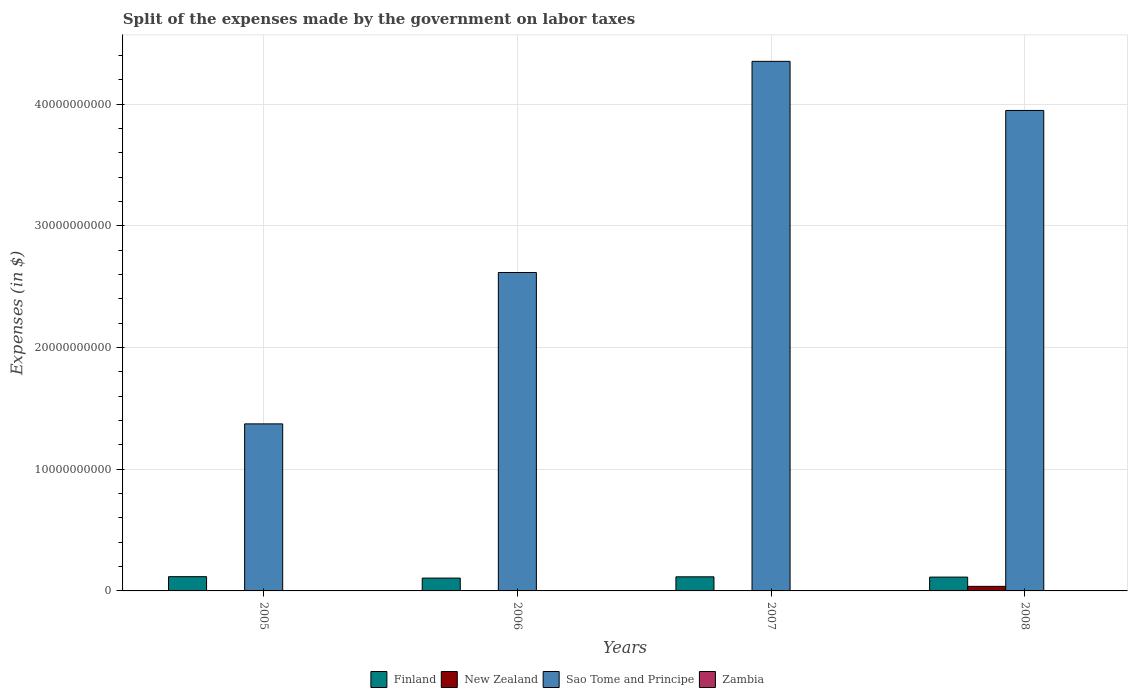Are the number of bars per tick equal to the number of legend labels?
Give a very brief answer. Yes. How many bars are there on the 4th tick from the left?
Ensure brevity in your answer.  4. In how many cases, is the number of bars for a given year not equal to the number of legend labels?
Offer a terse response. 0. What is the expenses made by the government on labor taxes in Finland in 2006?
Ensure brevity in your answer.  1.06e+09. Across all years, what is the maximum expenses made by the government on labor taxes in Sao Tome and Principe?
Keep it short and to the point. 4.35e+1. In which year was the expenses made by the government on labor taxes in Zambia minimum?
Offer a very short reply. 2005. What is the total expenses made by the government on labor taxes in Sao Tome and Principe in the graph?
Give a very brief answer. 1.23e+11. What is the difference between the expenses made by the government on labor taxes in Finland in 2007 and that in 2008?
Offer a terse response. 2.30e+07. What is the difference between the expenses made by the government on labor taxes in Zambia in 2008 and the expenses made by the government on labor taxes in Sao Tome and Principe in 2006?
Your answer should be compact. -2.61e+1. What is the average expenses made by the government on labor taxes in Zambia per year?
Your answer should be compact. 1.92e+07. In the year 2005, what is the difference between the expenses made by the government on labor taxes in Sao Tome and Principe and expenses made by the government on labor taxes in Finland?
Offer a terse response. 1.26e+1. In how many years, is the expenses made by the government on labor taxes in Zambia greater than 8000000000 $?
Offer a very short reply. 0. What is the ratio of the expenses made by the government on labor taxes in Finland in 2005 to that in 2008?
Give a very brief answer. 1.03. Is the difference between the expenses made by the government on labor taxes in Sao Tome and Principe in 2006 and 2008 greater than the difference between the expenses made by the government on labor taxes in Finland in 2006 and 2008?
Offer a terse response. No. What is the difference between the highest and the second highest expenses made by the government on labor taxes in Sao Tome and Principe?
Offer a terse response. 4.03e+09. What is the difference between the highest and the lowest expenses made by the government on labor taxes in New Zealand?
Your answer should be very brief. 3.73e+08. Is it the case that in every year, the sum of the expenses made by the government on labor taxes in Zambia and expenses made by the government on labor taxes in Sao Tome and Principe is greater than the sum of expenses made by the government on labor taxes in Finland and expenses made by the government on labor taxes in New Zealand?
Offer a terse response. Yes. What does the 2nd bar from the left in 2007 represents?
Your answer should be very brief. New Zealand. What does the 1st bar from the right in 2005 represents?
Provide a short and direct response. Zambia. Is it the case that in every year, the sum of the expenses made by the government on labor taxes in Finland and expenses made by the government on labor taxes in New Zealand is greater than the expenses made by the government on labor taxes in Zambia?
Offer a terse response. Yes. Does the graph contain any zero values?
Offer a very short reply. No. What is the title of the graph?
Provide a short and direct response. Split of the expenses made by the government on labor taxes. Does "Dominican Republic" appear as one of the legend labels in the graph?
Provide a short and direct response. No. What is the label or title of the Y-axis?
Your answer should be compact. Expenses (in $). What is the Expenses (in $) of Finland in 2005?
Make the answer very short. 1.17e+09. What is the Expenses (in $) in New Zealand in 2005?
Your response must be concise. 2.32e+06. What is the Expenses (in $) in Sao Tome and Principe in 2005?
Your answer should be very brief. 1.37e+1. What is the Expenses (in $) of Zambia in 2005?
Offer a terse response. 1.21e+07. What is the Expenses (in $) of Finland in 2006?
Your response must be concise. 1.06e+09. What is the Expenses (in $) in New Zealand in 2006?
Provide a succinct answer. 3.00e+06. What is the Expenses (in $) in Sao Tome and Principe in 2006?
Your answer should be very brief. 2.62e+1. What is the Expenses (in $) in Zambia in 2006?
Provide a short and direct response. 1.84e+07. What is the Expenses (in $) in Finland in 2007?
Offer a terse response. 1.16e+09. What is the Expenses (in $) in New Zealand in 2007?
Provide a succinct answer. 2.00e+06. What is the Expenses (in $) of Sao Tome and Principe in 2007?
Provide a succinct answer. 4.35e+1. What is the Expenses (in $) in Zambia in 2007?
Offer a very short reply. 2.33e+07. What is the Expenses (in $) of Finland in 2008?
Keep it short and to the point. 1.14e+09. What is the Expenses (in $) of New Zealand in 2008?
Make the answer very short. 3.75e+08. What is the Expenses (in $) in Sao Tome and Principe in 2008?
Ensure brevity in your answer.  3.95e+1. What is the Expenses (in $) in Zambia in 2008?
Give a very brief answer. 2.31e+07. Across all years, what is the maximum Expenses (in $) of Finland?
Keep it short and to the point. 1.17e+09. Across all years, what is the maximum Expenses (in $) of New Zealand?
Keep it short and to the point. 3.75e+08. Across all years, what is the maximum Expenses (in $) of Sao Tome and Principe?
Provide a succinct answer. 4.35e+1. Across all years, what is the maximum Expenses (in $) of Zambia?
Make the answer very short. 2.33e+07. Across all years, what is the minimum Expenses (in $) of Finland?
Keep it short and to the point. 1.06e+09. Across all years, what is the minimum Expenses (in $) of New Zealand?
Your answer should be very brief. 2.00e+06. Across all years, what is the minimum Expenses (in $) in Sao Tome and Principe?
Your response must be concise. 1.37e+1. Across all years, what is the minimum Expenses (in $) of Zambia?
Provide a succinct answer. 1.21e+07. What is the total Expenses (in $) in Finland in the graph?
Offer a very short reply. 4.52e+09. What is the total Expenses (in $) of New Zealand in the graph?
Keep it short and to the point. 3.82e+08. What is the total Expenses (in $) of Sao Tome and Principe in the graph?
Provide a short and direct response. 1.23e+11. What is the total Expenses (in $) of Zambia in the graph?
Offer a very short reply. 7.69e+07. What is the difference between the Expenses (in $) of Finland in 2005 and that in 2006?
Your answer should be compact. 1.15e+08. What is the difference between the Expenses (in $) in New Zealand in 2005 and that in 2006?
Your answer should be compact. -6.75e+05. What is the difference between the Expenses (in $) in Sao Tome and Principe in 2005 and that in 2006?
Give a very brief answer. -1.24e+1. What is the difference between the Expenses (in $) of Zambia in 2005 and that in 2006?
Ensure brevity in your answer.  -6.34e+06. What is the difference between the Expenses (in $) in New Zealand in 2005 and that in 2007?
Offer a very short reply. 3.25e+05. What is the difference between the Expenses (in $) in Sao Tome and Principe in 2005 and that in 2007?
Your response must be concise. -2.98e+1. What is the difference between the Expenses (in $) in Zambia in 2005 and that in 2007?
Provide a short and direct response. -1.13e+07. What is the difference between the Expenses (in $) of Finland in 2005 and that in 2008?
Offer a terse response. 3.50e+07. What is the difference between the Expenses (in $) in New Zealand in 2005 and that in 2008?
Offer a very short reply. -3.73e+08. What is the difference between the Expenses (in $) of Sao Tome and Principe in 2005 and that in 2008?
Your response must be concise. -2.57e+1. What is the difference between the Expenses (in $) of Zambia in 2005 and that in 2008?
Offer a terse response. -1.11e+07. What is the difference between the Expenses (in $) in Finland in 2006 and that in 2007?
Offer a very short reply. -1.03e+08. What is the difference between the Expenses (in $) in New Zealand in 2006 and that in 2007?
Your answer should be compact. 1.00e+06. What is the difference between the Expenses (in $) of Sao Tome and Principe in 2006 and that in 2007?
Your answer should be very brief. -1.73e+1. What is the difference between the Expenses (in $) of Zambia in 2006 and that in 2007?
Keep it short and to the point. -4.95e+06. What is the difference between the Expenses (in $) of Finland in 2006 and that in 2008?
Offer a very short reply. -8.00e+07. What is the difference between the Expenses (in $) in New Zealand in 2006 and that in 2008?
Your response must be concise. -3.72e+08. What is the difference between the Expenses (in $) in Sao Tome and Principe in 2006 and that in 2008?
Keep it short and to the point. -1.33e+1. What is the difference between the Expenses (in $) of Zambia in 2006 and that in 2008?
Provide a succinct answer. -4.72e+06. What is the difference between the Expenses (in $) in Finland in 2007 and that in 2008?
Your answer should be very brief. 2.30e+07. What is the difference between the Expenses (in $) in New Zealand in 2007 and that in 2008?
Your answer should be compact. -3.73e+08. What is the difference between the Expenses (in $) in Sao Tome and Principe in 2007 and that in 2008?
Make the answer very short. 4.03e+09. What is the difference between the Expenses (in $) in Zambia in 2007 and that in 2008?
Keep it short and to the point. 2.22e+05. What is the difference between the Expenses (in $) in Finland in 2005 and the Expenses (in $) in New Zealand in 2006?
Your answer should be compact. 1.17e+09. What is the difference between the Expenses (in $) in Finland in 2005 and the Expenses (in $) in Sao Tome and Principe in 2006?
Your answer should be very brief. -2.50e+1. What is the difference between the Expenses (in $) in Finland in 2005 and the Expenses (in $) in Zambia in 2006?
Provide a short and direct response. 1.15e+09. What is the difference between the Expenses (in $) of New Zealand in 2005 and the Expenses (in $) of Sao Tome and Principe in 2006?
Provide a succinct answer. -2.62e+1. What is the difference between the Expenses (in $) in New Zealand in 2005 and the Expenses (in $) in Zambia in 2006?
Keep it short and to the point. -1.61e+07. What is the difference between the Expenses (in $) in Sao Tome and Principe in 2005 and the Expenses (in $) in Zambia in 2006?
Your answer should be very brief. 1.37e+1. What is the difference between the Expenses (in $) of Finland in 2005 and the Expenses (in $) of New Zealand in 2007?
Your answer should be compact. 1.17e+09. What is the difference between the Expenses (in $) in Finland in 2005 and the Expenses (in $) in Sao Tome and Principe in 2007?
Give a very brief answer. -4.23e+1. What is the difference between the Expenses (in $) in Finland in 2005 and the Expenses (in $) in Zambia in 2007?
Ensure brevity in your answer.  1.15e+09. What is the difference between the Expenses (in $) in New Zealand in 2005 and the Expenses (in $) in Sao Tome and Principe in 2007?
Keep it short and to the point. -4.35e+1. What is the difference between the Expenses (in $) of New Zealand in 2005 and the Expenses (in $) of Zambia in 2007?
Make the answer very short. -2.10e+07. What is the difference between the Expenses (in $) in Sao Tome and Principe in 2005 and the Expenses (in $) in Zambia in 2007?
Provide a short and direct response. 1.37e+1. What is the difference between the Expenses (in $) in Finland in 2005 and the Expenses (in $) in New Zealand in 2008?
Your response must be concise. 7.95e+08. What is the difference between the Expenses (in $) in Finland in 2005 and the Expenses (in $) in Sao Tome and Principe in 2008?
Ensure brevity in your answer.  -3.83e+1. What is the difference between the Expenses (in $) in Finland in 2005 and the Expenses (in $) in Zambia in 2008?
Offer a very short reply. 1.15e+09. What is the difference between the Expenses (in $) of New Zealand in 2005 and the Expenses (in $) of Sao Tome and Principe in 2008?
Give a very brief answer. -3.95e+1. What is the difference between the Expenses (in $) of New Zealand in 2005 and the Expenses (in $) of Zambia in 2008?
Provide a succinct answer. -2.08e+07. What is the difference between the Expenses (in $) in Sao Tome and Principe in 2005 and the Expenses (in $) in Zambia in 2008?
Your answer should be very brief. 1.37e+1. What is the difference between the Expenses (in $) of Finland in 2006 and the Expenses (in $) of New Zealand in 2007?
Offer a very short reply. 1.05e+09. What is the difference between the Expenses (in $) of Finland in 2006 and the Expenses (in $) of Sao Tome and Principe in 2007?
Your response must be concise. -4.25e+1. What is the difference between the Expenses (in $) in Finland in 2006 and the Expenses (in $) in Zambia in 2007?
Provide a succinct answer. 1.03e+09. What is the difference between the Expenses (in $) of New Zealand in 2006 and the Expenses (in $) of Sao Tome and Principe in 2007?
Your answer should be very brief. -4.35e+1. What is the difference between the Expenses (in $) in New Zealand in 2006 and the Expenses (in $) in Zambia in 2007?
Offer a terse response. -2.03e+07. What is the difference between the Expenses (in $) of Sao Tome and Principe in 2006 and the Expenses (in $) of Zambia in 2007?
Your response must be concise. 2.61e+1. What is the difference between the Expenses (in $) of Finland in 2006 and the Expenses (in $) of New Zealand in 2008?
Offer a terse response. 6.80e+08. What is the difference between the Expenses (in $) of Finland in 2006 and the Expenses (in $) of Sao Tome and Principe in 2008?
Provide a succinct answer. -3.84e+1. What is the difference between the Expenses (in $) in Finland in 2006 and the Expenses (in $) in Zambia in 2008?
Give a very brief answer. 1.03e+09. What is the difference between the Expenses (in $) in New Zealand in 2006 and the Expenses (in $) in Sao Tome and Principe in 2008?
Provide a succinct answer. -3.95e+1. What is the difference between the Expenses (in $) of New Zealand in 2006 and the Expenses (in $) of Zambia in 2008?
Make the answer very short. -2.01e+07. What is the difference between the Expenses (in $) in Sao Tome and Principe in 2006 and the Expenses (in $) in Zambia in 2008?
Provide a succinct answer. 2.61e+1. What is the difference between the Expenses (in $) of Finland in 2007 and the Expenses (in $) of New Zealand in 2008?
Offer a terse response. 7.83e+08. What is the difference between the Expenses (in $) in Finland in 2007 and the Expenses (in $) in Sao Tome and Principe in 2008?
Your response must be concise. -3.83e+1. What is the difference between the Expenses (in $) of Finland in 2007 and the Expenses (in $) of Zambia in 2008?
Keep it short and to the point. 1.13e+09. What is the difference between the Expenses (in $) in New Zealand in 2007 and the Expenses (in $) in Sao Tome and Principe in 2008?
Make the answer very short. -3.95e+1. What is the difference between the Expenses (in $) in New Zealand in 2007 and the Expenses (in $) in Zambia in 2008?
Offer a terse response. -2.11e+07. What is the difference between the Expenses (in $) of Sao Tome and Principe in 2007 and the Expenses (in $) of Zambia in 2008?
Offer a very short reply. 4.35e+1. What is the average Expenses (in $) in Finland per year?
Give a very brief answer. 1.13e+09. What is the average Expenses (in $) of New Zealand per year?
Provide a succinct answer. 9.56e+07. What is the average Expenses (in $) in Sao Tome and Principe per year?
Ensure brevity in your answer.  3.07e+1. What is the average Expenses (in $) of Zambia per year?
Provide a short and direct response. 1.92e+07. In the year 2005, what is the difference between the Expenses (in $) of Finland and Expenses (in $) of New Zealand?
Provide a short and direct response. 1.17e+09. In the year 2005, what is the difference between the Expenses (in $) of Finland and Expenses (in $) of Sao Tome and Principe?
Provide a succinct answer. -1.26e+1. In the year 2005, what is the difference between the Expenses (in $) in Finland and Expenses (in $) in Zambia?
Offer a very short reply. 1.16e+09. In the year 2005, what is the difference between the Expenses (in $) of New Zealand and Expenses (in $) of Sao Tome and Principe?
Make the answer very short. -1.37e+1. In the year 2005, what is the difference between the Expenses (in $) in New Zealand and Expenses (in $) in Zambia?
Give a very brief answer. -9.73e+06. In the year 2005, what is the difference between the Expenses (in $) in Sao Tome and Principe and Expenses (in $) in Zambia?
Your answer should be very brief. 1.37e+1. In the year 2006, what is the difference between the Expenses (in $) of Finland and Expenses (in $) of New Zealand?
Ensure brevity in your answer.  1.05e+09. In the year 2006, what is the difference between the Expenses (in $) of Finland and Expenses (in $) of Sao Tome and Principe?
Your answer should be compact. -2.51e+1. In the year 2006, what is the difference between the Expenses (in $) in Finland and Expenses (in $) in Zambia?
Your response must be concise. 1.04e+09. In the year 2006, what is the difference between the Expenses (in $) in New Zealand and Expenses (in $) in Sao Tome and Principe?
Provide a succinct answer. -2.62e+1. In the year 2006, what is the difference between the Expenses (in $) of New Zealand and Expenses (in $) of Zambia?
Offer a very short reply. -1.54e+07. In the year 2006, what is the difference between the Expenses (in $) of Sao Tome and Principe and Expenses (in $) of Zambia?
Provide a succinct answer. 2.61e+1. In the year 2007, what is the difference between the Expenses (in $) in Finland and Expenses (in $) in New Zealand?
Offer a very short reply. 1.16e+09. In the year 2007, what is the difference between the Expenses (in $) of Finland and Expenses (in $) of Sao Tome and Principe?
Ensure brevity in your answer.  -4.23e+1. In the year 2007, what is the difference between the Expenses (in $) in Finland and Expenses (in $) in Zambia?
Your answer should be very brief. 1.13e+09. In the year 2007, what is the difference between the Expenses (in $) in New Zealand and Expenses (in $) in Sao Tome and Principe?
Offer a terse response. -4.35e+1. In the year 2007, what is the difference between the Expenses (in $) in New Zealand and Expenses (in $) in Zambia?
Your answer should be compact. -2.13e+07. In the year 2007, what is the difference between the Expenses (in $) in Sao Tome and Principe and Expenses (in $) in Zambia?
Your response must be concise. 4.35e+1. In the year 2008, what is the difference between the Expenses (in $) in Finland and Expenses (in $) in New Zealand?
Ensure brevity in your answer.  7.60e+08. In the year 2008, what is the difference between the Expenses (in $) of Finland and Expenses (in $) of Sao Tome and Principe?
Offer a very short reply. -3.83e+1. In the year 2008, what is the difference between the Expenses (in $) of Finland and Expenses (in $) of Zambia?
Provide a succinct answer. 1.11e+09. In the year 2008, what is the difference between the Expenses (in $) in New Zealand and Expenses (in $) in Sao Tome and Principe?
Your answer should be very brief. -3.91e+1. In the year 2008, what is the difference between the Expenses (in $) of New Zealand and Expenses (in $) of Zambia?
Ensure brevity in your answer.  3.52e+08. In the year 2008, what is the difference between the Expenses (in $) of Sao Tome and Principe and Expenses (in $) of Zambia?
Offer a very short reply. 3.94e+1. What is the ratio of the Expenses (in $) in Finland in 2005 to that in 2006?
Your response must be concise. 1.11. What is the ratio of the Expenses (in $) of New Zealand in 2005 to that in 2006?
Your answer should be compact. 0.78. What is the ratio of the Expenses (in $) in Sao Tome and Principe in 2005 to that in 2006?
Keep it short and to the point. 0.52. What is the ratio of the Expenses (in $) in Zambia in 2005 to that in 2006?
Provide a short and direct response. 0.66. What is the ratio of the Expenses (in $) in Finland in 2005 to that in 2007?
Provide a short and direct response. 1.01. What is the ratio of the Expenses (in $) of New Zealand in 2005 to that in 2007?
Offer a terse response. 1.16. What is the ratio of the Expenses (in $) of Sao Tome and Principe in 2005 to that in 2007?
Make the answer very short. 0.32. What is the ratio of the Expenses (in $) in Zambia in 2005 to that in 2007?
Ensure brevity in your answer.  0.52. What is the ratio of the Expenses (in $) of Finland in 2005 to that in 2008?
Give a very brief answer. 1.03. What is the ratio of the Expenses (in $) in New Zealand in 2005 to that in 2008?
Your response must be concise. 0.01. What is the ratio of the Expenses (in $) in Sao Tome and Principe in 2005 to that in 2008?
Your answer should be very brief. 0.35. What is the ratio of the Expenses (in $) of Zambia in 2005 to that in 2008?
Ensure brevity in your answer.  0.52. What is the ratio of the Expenses (in $) of Finland in 2006 to that in 2007?
Make the answer very short. 0.91. What is the ratio of the Expenses (in $) in New Zealand in 2006 to that in 2007?
Your answer should be very brief. 1.5. What is the ratio of the Expenses (in $) in Sao Tome and Principe in 2006 to that in 2007?
Provide a short and direct response. 0.6. What is the ratio of the Expenses (in $) of Zambia in 2006 to that in 2007?
Offer a terse response. 0.79. What is the ratio of the Expenses (in $) in Finland in 2006 to that in 2008?
Offer a terse response. 0.93. What is the ratio of the Expenses (in $) in New Zealand in 2006 to that in 2008?
Keep it short and to the point. 0.01. What is the ratio of the Expenses (in $) of Sao Tome and Principe in 2006 to that in 2008?
Provide a short and direct response. 0.66. What is the ratio of the Expenses (in $) of Zambia in 2006 to that in 2008?
Offer a terse response. 0.8. What is the ratio of the Expenses (in $) in Finland in 2007 to that in 2008?
Offer a terse response. 1.02. What is the ratio of the Expenses (in $) in New Zealand in 2007 to that in 2008?
Your response must be concise. 0.01. What is the ratio of the Expenses (in $) of Sao Tome and Principe in 2007 to that in 2008?
Give a very brief answer. 1.1. What is the ratio of the Expenses (in $) in Zambia in 2007 to that in 2008?
Provide a succinct answer. 1.01. What is the difference between the highest and the second highest Expenses (in $) of New Zealand?
Give a very brief answer. 3.72e+08. What is the difference between the highest and the second highest Expenses (in $) in Sao Tome and Principe?
Give a very brief answer. 4.03e+09. What is the difference between the highest and the second highest Expenses (in $) of Zambia?
Your answer should be very brief. 2.22e+05. What is the difference between the highest and the lowest Expenses (in $) in Finland?
Offer a terse response. 1.15e+08. What is the difference between the highest and the lowest Expenses (in $) in New Zealand?
Keep it short and to the point. 3.73e+08. What is the difference between the highest and the lowest Expenses (in $) in Sao Tome and Principe?
Ensure brevity in your answer.  2.98e+1. What is the difference between the highest and the lowest Expenses (in $) of Zambia?
Your answer should be compact. 1.13e+07. 